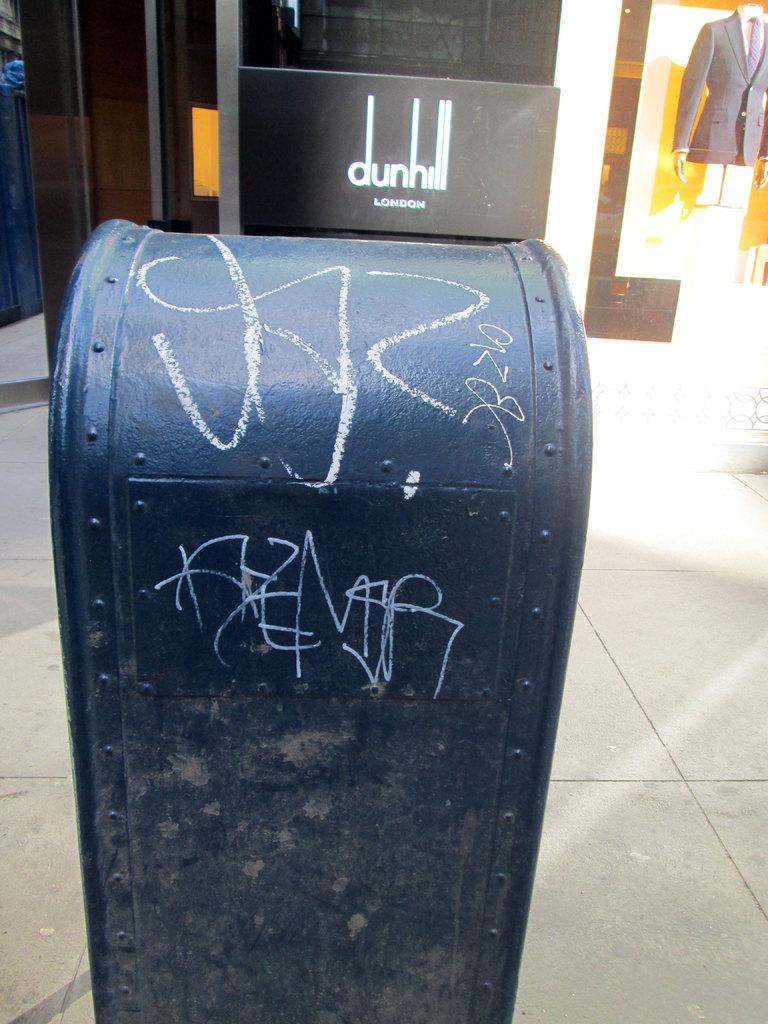Where is dunhill located?
Keep it short and to the point. London. 